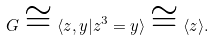Convert formula to latex. <formula><loc_0><loc_0><loc_500><loc_500>G \cong \langle z , y | z ^ { 3 } = y \rangle \cong \langle z \rangle .</formula> 